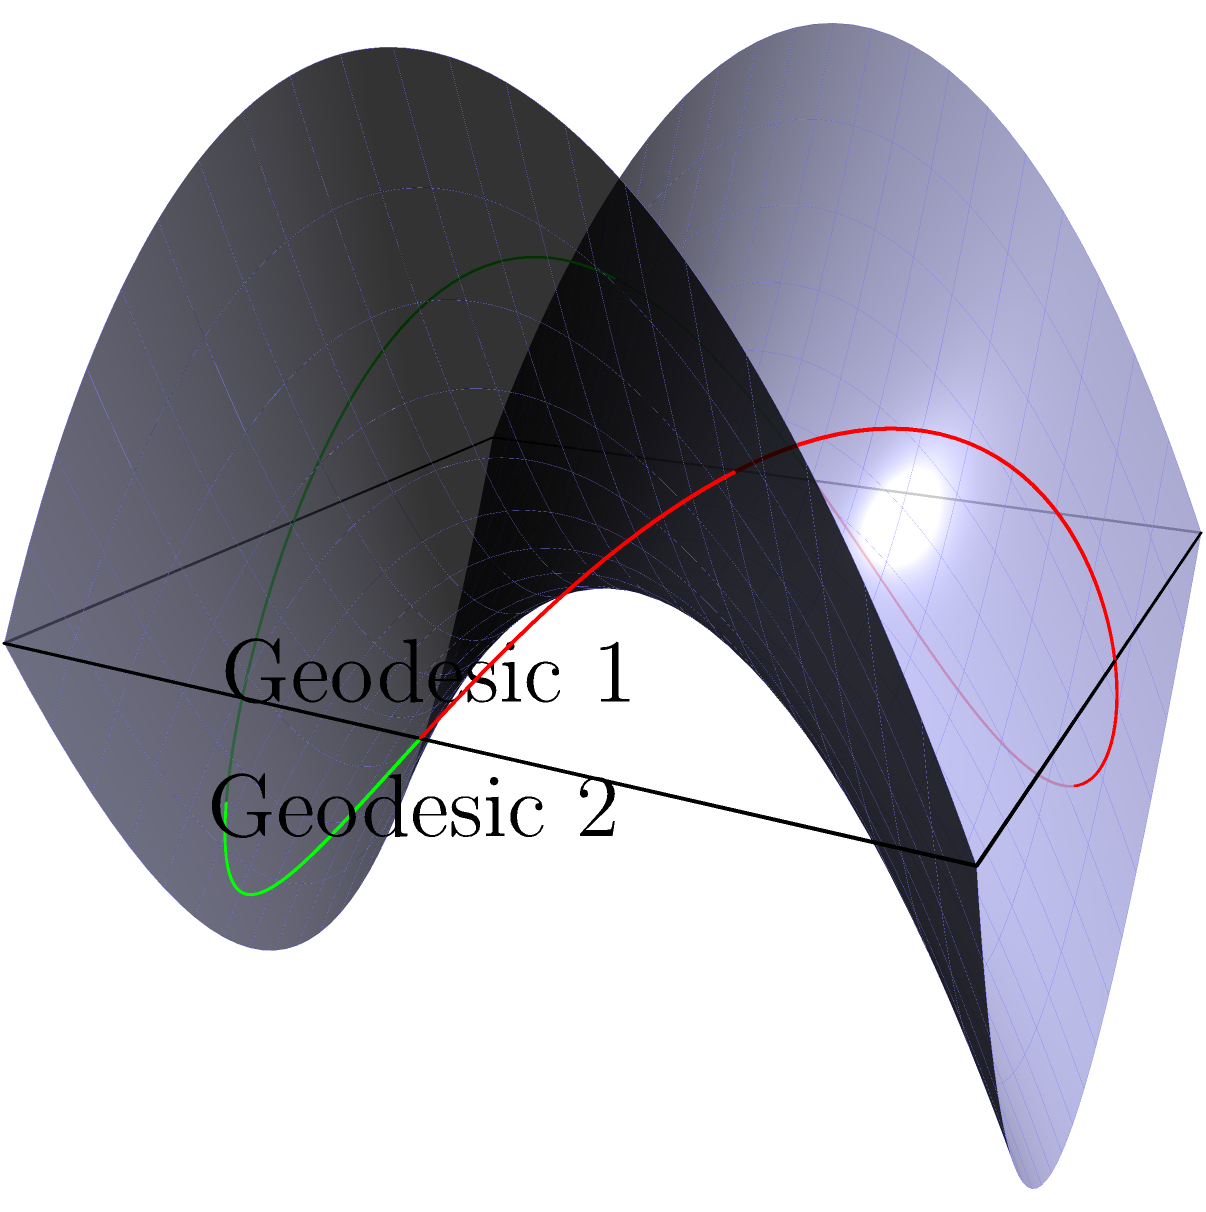Consider the saddle-shaped surface given by the equation $z = x^2 - y^2$. Two geodesics are shown on this surface: one in red (Geodesic 1) and one in green (Geodesic 2). How do these geodesics differ from straight lines in Euclidean space, and what implications does this have for the nature of Non-Euclidean Geometry on curved surfaces? To understand the behavior of geodesics on a saddle-shaped surface compared to straight lines in Euclidean space, let's follow these steps:

1. Definition: In Euclidean geometry, the shortest path between two points is a straight line. On curved surfaces, geodesics play a similar role, representing the shortest path between two points on that surface.

2. Saddle surface: The surface $z = x^2 - y^2$ is a hyperbolic paraboloid, or saddle surface. It has negative curvature at all points.

3. Geodesic behavior:
   a) Geodesic 1 (red) curves upward in the positive z-direction.
   b) Geodesic 2 (green) curves downward in the negative z-direction.

4. Comparison to Euclidean straight lines:
   a) Euclidean straight lines would appear as straight paths when projected onto the xy-plane.
   b) The geodesics on this surface, when projected onto the xy-plane, would appear curved.

5. Implications for Non-Euclidean Geometry:
   a) Parallel postulate: On this surface, given a geodesic and a point not on it, there can be infinitely many geodesics through the point that do not intersect the original geodesic, violating Euclid's parallel postulate.
   b) Sum of angles: The sum of angles in a triangle formed by geodesics on this surface would be less than 180°, unlike in Euclidean geometry.
   c) Distance: The notion of distance is fundamentally different, as the shortest path between two points is not a Euclidean straight line but a curved geodesic.

6. Mathematical properties:
   a) Geodesics on this surface satisfy the geodesic equation: 
      $$\frac{d^2x^i}{ds^2} + \Gamma^i_{jk}\frac{dx^j}{ds}\frac{dx^k}{ds} = 0$$
      where $\Gamma^i_{jk}$ are the Christoffel symbols and $s$ is the arc length.
   b) The curvature of the surface affects the behavior of geodesics, causing them to deviate from Euclidean straight lines.

This analysis demonstrates that Non-Euclidean Geometry on curved surfaces, such as this saddle shape, fundamentally differs from Euclidean geometry in its basic properties and behaviors of geodesics.
Answer: Geodesics on the saddle surface curve in 3D space, unlike Euclidean straight lines, demonstrating fundamental differences in distance, parallelism, and angular properties in Non-Euclidean Geometry. 